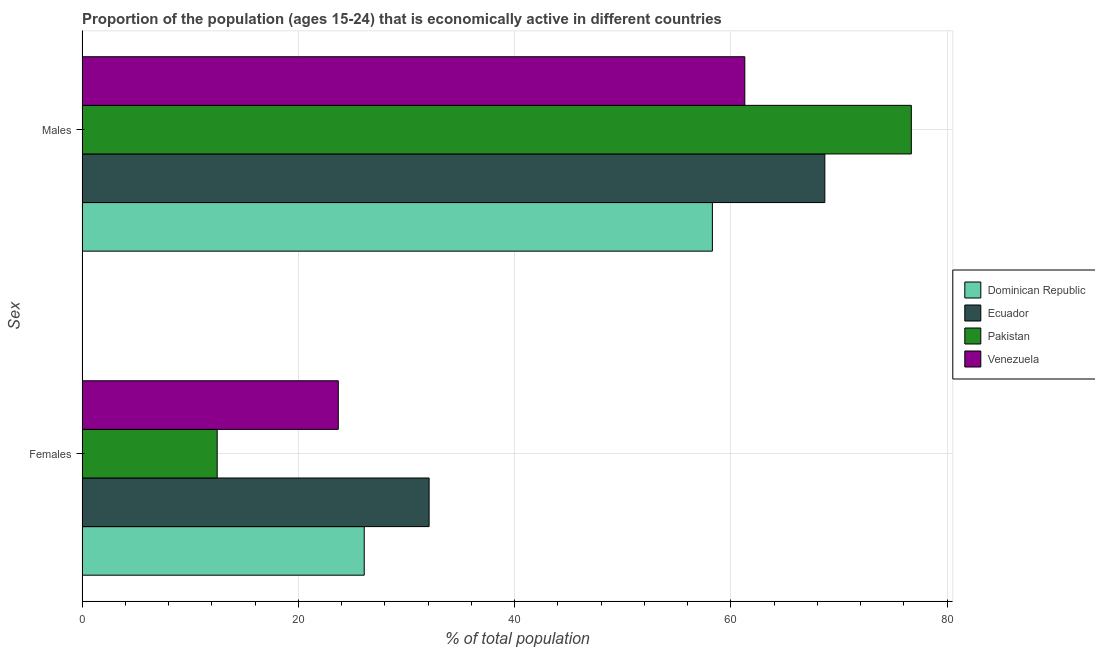How many different coloured bars are there?
Keep it short and to the point. 4. How many bars are there on the 1st tick from the top?
Your answer should be compact. 4. How many bars are there on the 2nd tick from the bottom?
Provide a short and direct response. 4. What is the label of the 2nd group of bars from the top?
Your response must be concise. Females. What is the percentage of economically active male population in Dominican Republic?
Your response must be concise. 58.3. Across all countries, what is the maximum percentage of economically active male population?
Give a very brief answer. 76.7. Across all countries, what is the minimum percentage of economically active male population?
Give a very brief answer. 58.3. In which country was the percentage of economically active female population maximum?
Provide a short and direct response. Ecuador. In which country was the percentage of economically active male population minimum?
Offer a terse response. Dominican Republic. What is the total percentage of economically active female population in the graph?
Give a very brief answer. 94.4. What is the difference between the percentage of economically active female population in Venezuela and that in Dominican Republic?
Ensure brevity in your answer.  -2.4. What is the difference between the percentage of economically active male population in Pakistan and the percentage of economically active female population in Venezuela?
Keep it short and to the point. 53. What is the average percentage of economically active male population per country?
Offer a terse response. 66.25. What is the difference between the percentage of economically active female population and percentage of economically active male population in Pakistan?
Offer a terse response. -64.2. In how many countries, is the percentage of economically active female population greater than 16 %?
Your answer should be very brief. 3. What is the ratio of the percentage of economically active male population in Venezuela to that in Ecuador?
Make the answer very short. 0.89. In how many countries, is the percentage of economically active female population greater than the average percentage of economically active female population taken over all countries?
Offer a very short reply. 3. What does the 1st bar from the top in Males represents?
Give a very brief answer. Venezuela. How many bars are there?
Your response must be concise. 8. Are all the bars in the graph horizontal?
Provide a succinct answer. Yes. How many countries are there in the graph?
Offer a terse response. 4. What is the difference between two consecutive major ticks on the X-axis?
Provide a short and direct response. 20. Where does the legend appear in the graph?
Provide a succinct answer. Center right. What is the title of the graph?
Your answer should be compact. Proportion of the population (ages 15-24) that is economically active in different countries. Does "Brazil" appear as one of the legend labels in the graph?
Give a very brief answer. No. What is the label or title of the X-axis?
Offer a terse response. % of total population. What is the label or title of the Y-axis?
Make the answer very short. Sex. What is the % of total population of Dominican Republic in Females?
Your answer should be very brief. 26.1. What is the % of total population of Ecuador in Females?
Ensure brevity in your answer.  32.1. What is the % of total population of Pakistan in Females?
Offer a terse response. 12.5. What is the % of total population of Venezuela in Females?
Keep it short and to the point. 23.7. What is the % of total population of Dominican Republic in Males?
Your answer should be very brief. 58.3. What is the % of total population of Ecuador in Males?
Give a very brief answer. 68.7. What is the % of total population of Pakistan in Males?
Offer a very short reply. 76.7. What is the % of total population of Venezuela in Males?
Make the answer very short. 61.3. Across all Sex, what is the maximum % of total population of Dominican Republic?
Your answer should be compact. 58.3. Across all Sex, what is the maximum % of total population of Ecuador?
Your answer should be very brief. 68.7. Across all Sex, what is the maximum % of total population of Pakistan?
Your answer should be very brief. 76.7. Across all Sex, what is the maximum % of total population of Venezuela?
Ensure brevity in your answer.  61.3. Across all Sex, what is the minimum % of total population of Dominican Republic?
Ensure brevity in your answer.  26.1. Across all Sex, what is the minimum % of total population in Ecuador?
Your answer should be very brief. 32.1. Across all Sex, what is the minimum % of total population of Venezuela?
Your response must be concise. 23.7. What is the total % of total population of Dominican Republic in the graph?
Make the answer very short. 84.4. What is the total % of total population of Ecuador in the graph?
Your response must be concise. 100.8. What is the total % of total population of Pakistan in the graph?
Offer a very short reply. 89.2. What is the difference between the % of total population in Dominican Republic in Females and that in Males?
Offer a terse response. -32.2. What is the difference between the % of total population of Ecuador in Females and that in Males?
Your answer should be very brief. -36.6. What is the difference between the % of total population in Pakistan in Females and that in Males?
Give a very brief answer. -64.2. What is the difference between the % of total population of Venezuela in Females and that in Males?
Provide a short and direct response. -37.6. What is the difference between the % of total population in Dominican Republic in Females and the % of total population in Ecuador in Males?
Offer a terse response. -42.6. What is the difference between the % of total population of Dominican Republic in Females and the % of total population of Pakistan in Males?
Make the answer very short. -50.6. What is the difference between the % of total population of Dominican Republic in Females and the % of total population of Venezuela in Males?
Your answer should be compact. -35.2. What is the difference between the % of total population of Ecuador in Females and the % of total population of Pakistan in Males?
Keep it short and to the point. -44.6. What is the difference between the % of total population in Ecuador in Females and the % of total population in Venezuela in Males?
Your answer should be compact. -29.2. What is the difference between the % of total population in Pakistan in Females and the % of total population in Venezuela in Males?
Your answer should be compact. -48.8. What is the average % of total population in Dominican Republic per Sex?
Provide a short and direct response. 42.2. What is the average % of total population in Ecuador per Sex?
Your answer should be compact. 50.4. What is the average % of total population of Pakistan per Sex?
Make the answer very short. 44.6. What is the average % of total population of Venezuela per Sex?
Provide a short and direct response. 42.5. What is the difference between the % of total population in Dominican Republic and % of total population in Ecuador in Females?
Provide a succinct answer. -6. What is the difference between the % of total population of Dominican Republic and % of total population of Pakistan in Females?
Provide a succinct answer. 13.6. What is the difference between the % of total population in Ecuador and % of total population in Pakistan in Females?
Ensure brevity in your answer.  19.6. What is the difference between the % of total population in Pakistan and % of total population in Venezuela in Females?
Offer a terse response. -11.2. What is the difference between the % of total population of Dominican Republic and % of total population of Pakistan in Males?
Give a very brief answer. -18.4. What is the difference between the % of total population of Ecuador and % of total population of Venezuela in Males?
Provide a short and direct response. 7.4. What is the ratio of the % of total population of Dominican Republic in Females to that in Males?
Ensure brevity in your answer.  0.45. What is the ratio of the % of total population in Ecuador in Females to that in Males?
Offer a very short reply. 0.47. What is the ratio of the % of total population of Pakistan in Females to that in Males?
Ensure brevity in your answer.  0.16. What is the ratio of the % of total population of Venezuela in Females to that in Males?
Provide a short and direct response. 0.39. What is the difference between the highest and the second highest % of total population in Dominican Republic?
Your response must be concise. 32.2. What is the difference between the highest and the second highest % of total population in Ecuador?
Your answer should be compact. 36.6. What is the difference between the highest and the second highest % of total population in Pakistan?
Make the answer very short. 64.2. What is the difference between the highest and the second highest % of total population of Venezuela?
Keep it short and to the point. 37.6. What is the difference between the highest and the lowest % of total population in Dominican Republic?
Keep it short and to the point. 32.2. What is the difference between the highest and the lowest % of total population of Ecuador?
Provide a succinct answer. 36.6. What is the difference between the highest and the lowest % of total population in Pakistan?
Offer a terse response. 64.2. What is the difference between the highest and the lowest % of total population in Venezuela?
Offer a very short reply. 37.6. 